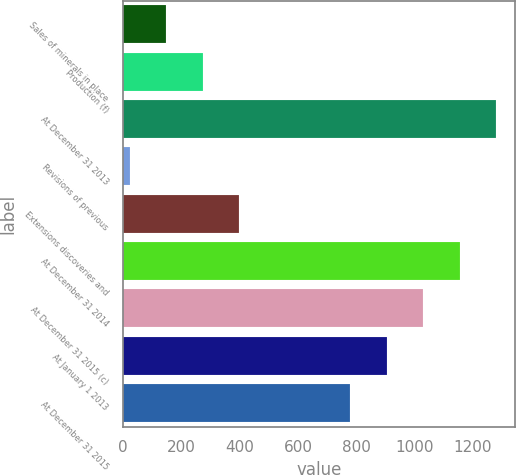Convert chart to OTSL. <chart><loc_0><loc_0><loc_500><loc_500><bar_chart><fcel>Sales of minerals in place<fcel>Production (f)<fcel>At December 31 2013<fcel>Revisions of previous<fcel>Extensions discoveries and<fcel>At December 31 2014<fcel>At December 31 2015 (c)<fcel>At January 1 2013<fcel>At December 31 2015<nl><fcel>148<fcel>273<fcel>1280<fcel>23<fcel>398<fcel>1155<fcel>1030<fcel>905<fcel>780<nl></chart> 